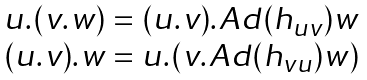<formula> <loc_0><loc_0><loc_500><loc_500>\begin{array} { c } u . ( v . w ) = ( u . v ) . A d ( h _ { u v } ) w \\ ( u . v ) . w = u . ( v . A d ( h _ { v u } ) w ) \end{array}</formula> 